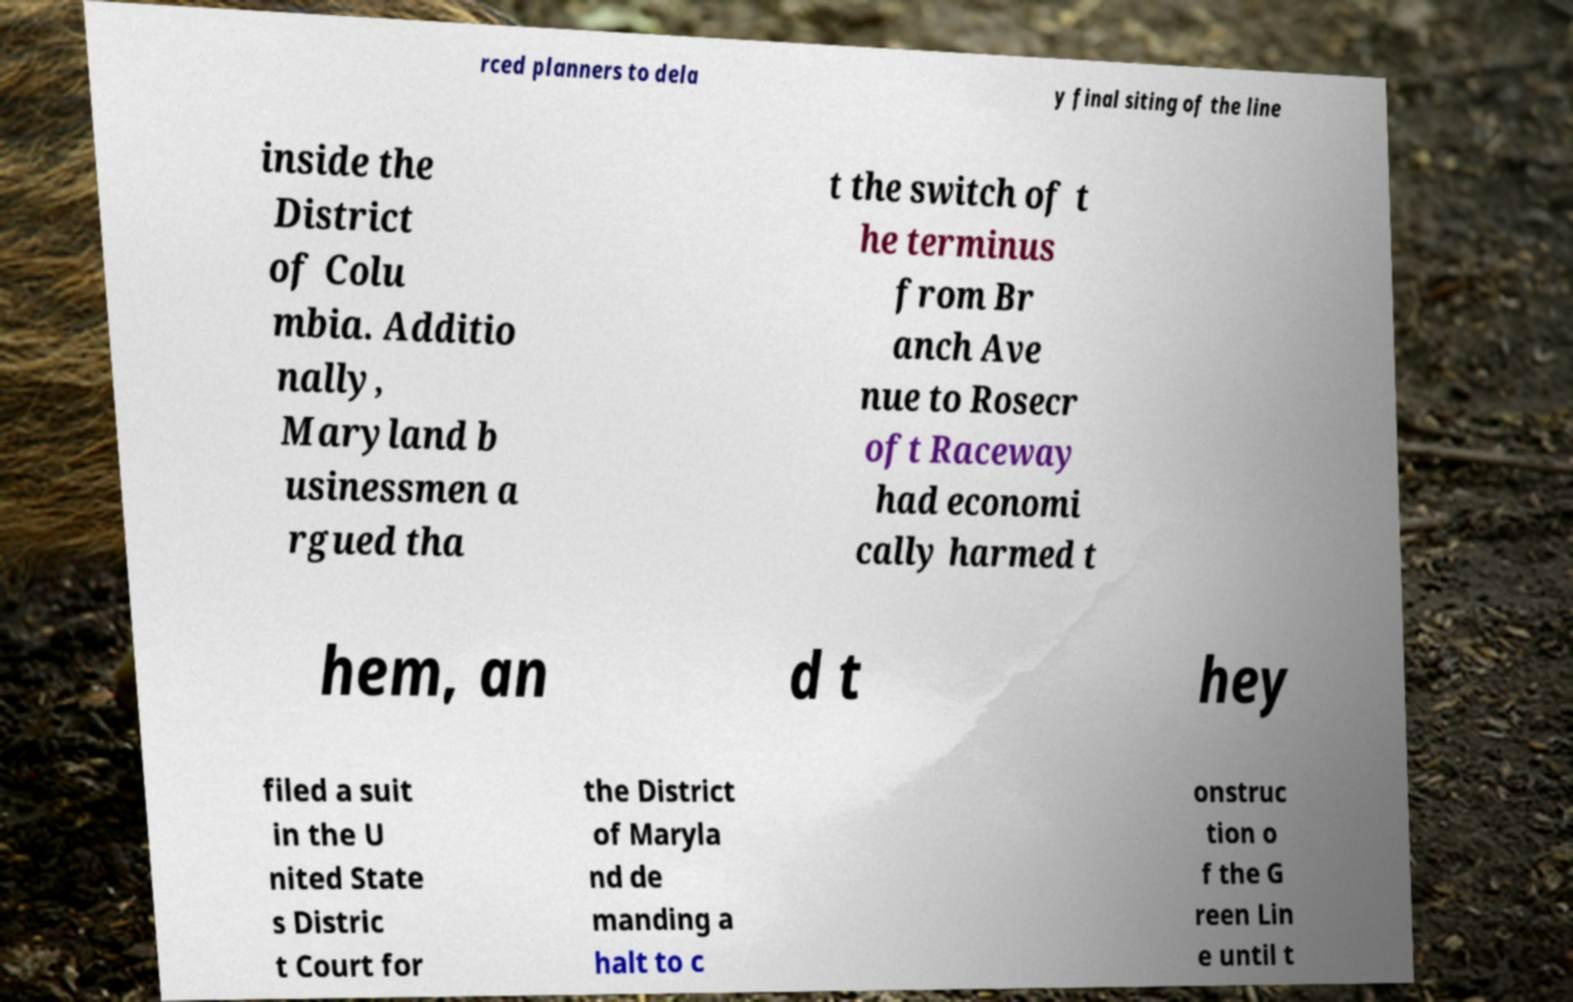I need the written content from this picture converted into text. Can you do that? rced planners to dela y final siting of the line inside the District of Colu mbia. Additio nally, Maryland b usinessmen a rgued tha t the switch of t he terminus from Br anch Ave nue to Rosecr oft Raceway had economi cally harmed t hem, an d t hey filed a suit in the U nited State s Distric t Court for the District of Maryla nd de manding a halt to c onstruc tion o f the G reen Lin e until t 